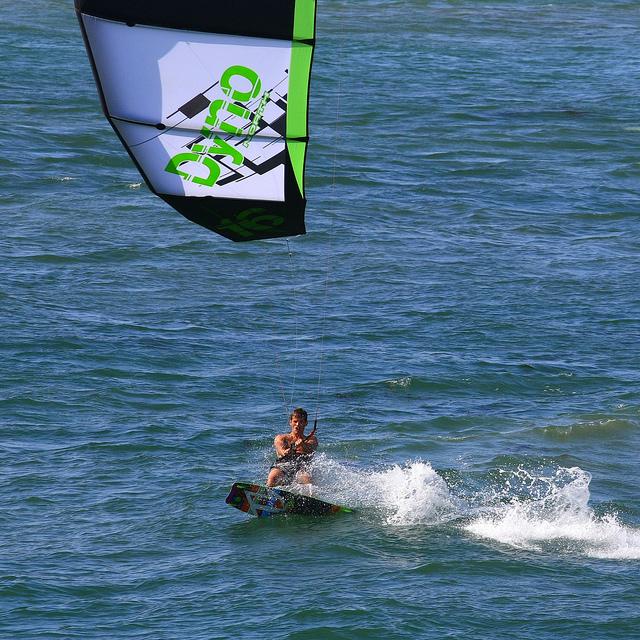What is the surfer holding while surfing?
Concise answer only. Kite. Is he flying a kite?
Quick response, please. No. What natural condition(s) must be present for this type of water sport to take place?
Concise answer only. Wind. 